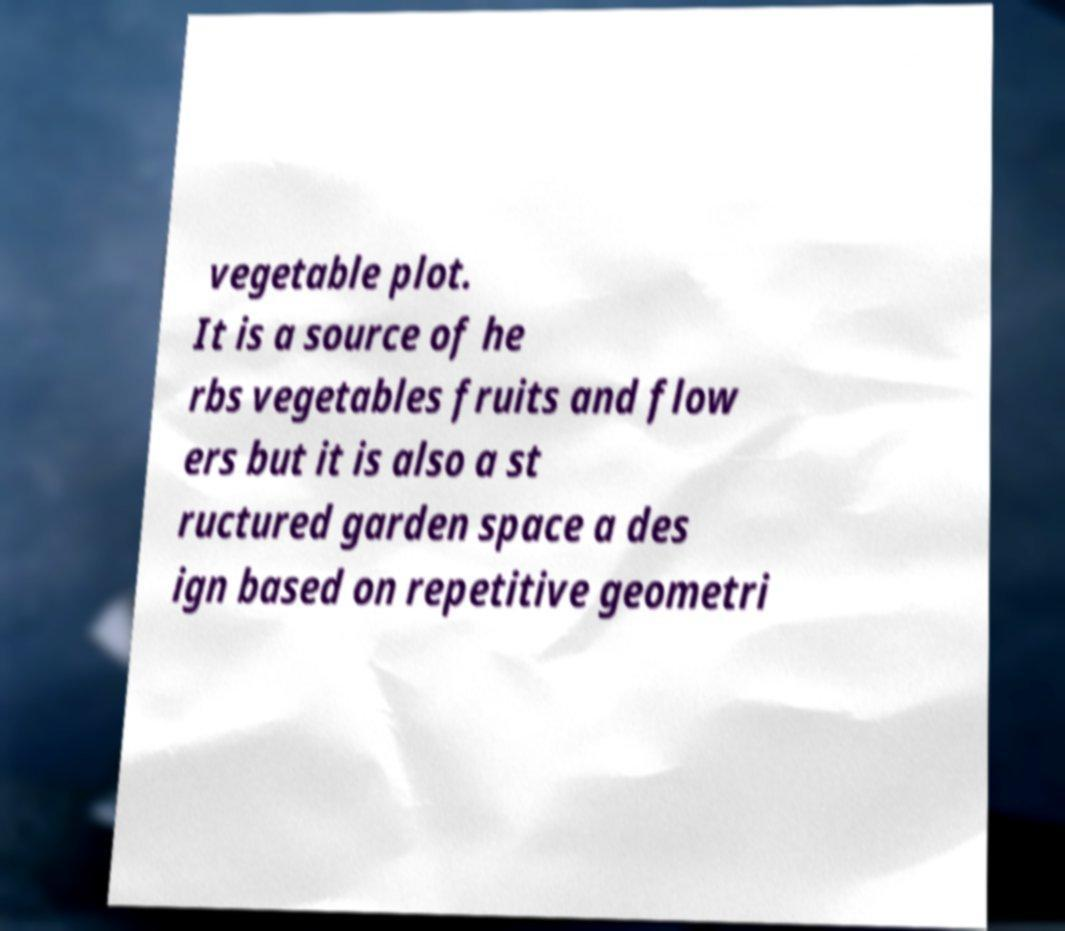What messages or text are displayed in this image? I need them in a readable, typed format. vegetable plot. It is a source of he rbs vegetables fruits and flow ers but it is also a st ructured garden space a des ign based on repetitive geometri 